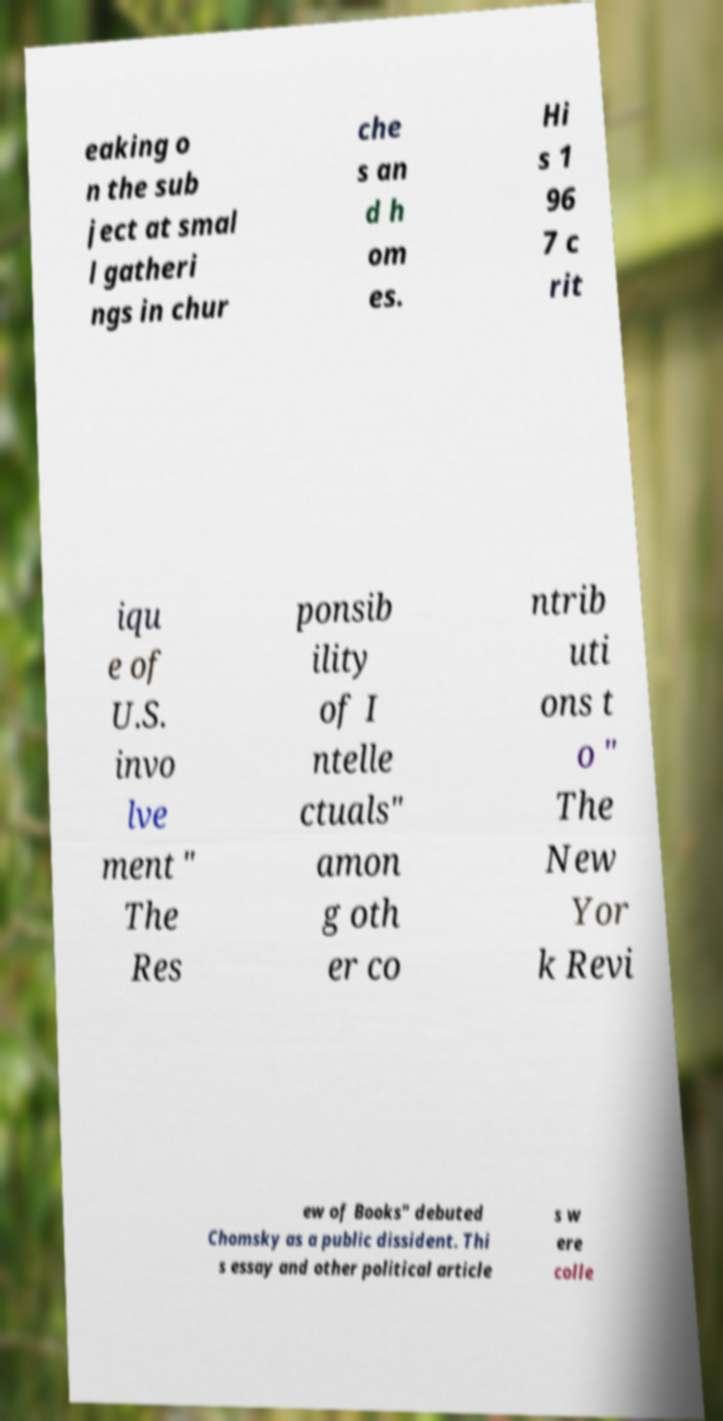For documentation purposes, I need the text within this image transcribed. Could you provide that? eaking o n the sub ject at smal l gatheri ngs in chur che s an d h om es. Hi s 1 96 7 c rit iqu e of U.S. invo lve ment " The Res ponsib ility of I ntelle ctuals" amon g oth er co ntrib uti ons t o " The New Yor k Revi ew of Books" debuted Chomsky as a public dissident. Thi s essay and other political article s w ere colle 